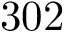Convert formula to latex. <formula><loc_0><loc_0><loc_500><loc_500>3 0 2</formula> 